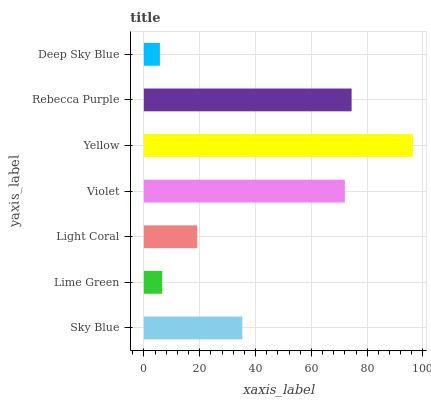Is Deep Sky Blue the minimum?
Answer yes or no. Yes. Is Yellow the maximum?
Answer yes or no. Yes. Is Lime Green the minimum?
Answer yes or no. No. Is Lime Green the maximum?
Answer yes or no. No. Is Sky Blue greater than Lime Green?
Answer yes or no. Yes. Is Lime Green less than Sky Blue?
Answer yes or no. Yes. Is Lime Green greater than Sky Blue?
Answer yes or no. No. Is Sky Blue less than Lime Green?
Answer yes or no. No. Is Sky Blue the high median?
Answer yes or no. Yes. Is Sky Blue the low median?
Answer yes or no. Yes. Is Lime Green the high median?
Answer yes or no. No. Is Violet the low median?
Answer yes or no. No. 